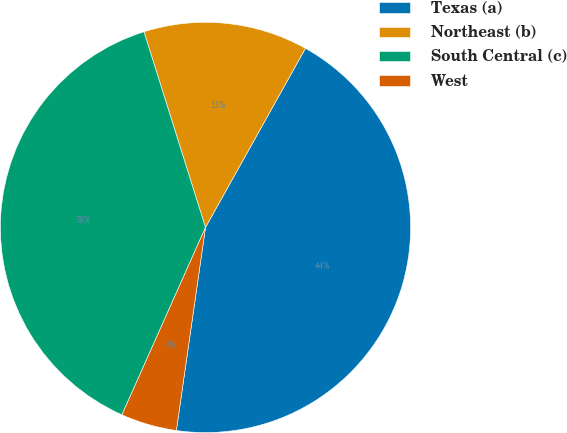<chart> <loc_0><loc_0><loc_500><loc_500><pie_chart><fcel>Texas (a)<fcel>Northeast (b)<fcel>South Central (c)<fcel>West<nl><fcel>44.17%<fcel>12.95%<fcel>38.48%<fcel>4.41%<nl></chart> 